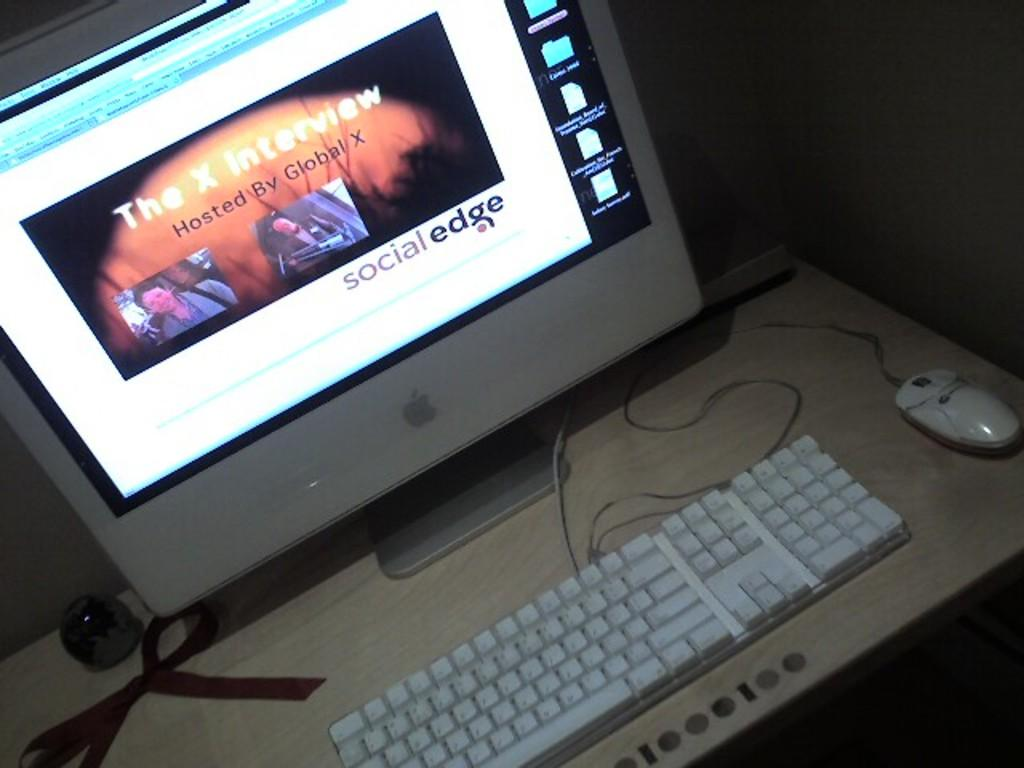<image>
Offer a succinct explanation of the picture presented. The website is titled Social Edge with a white background 